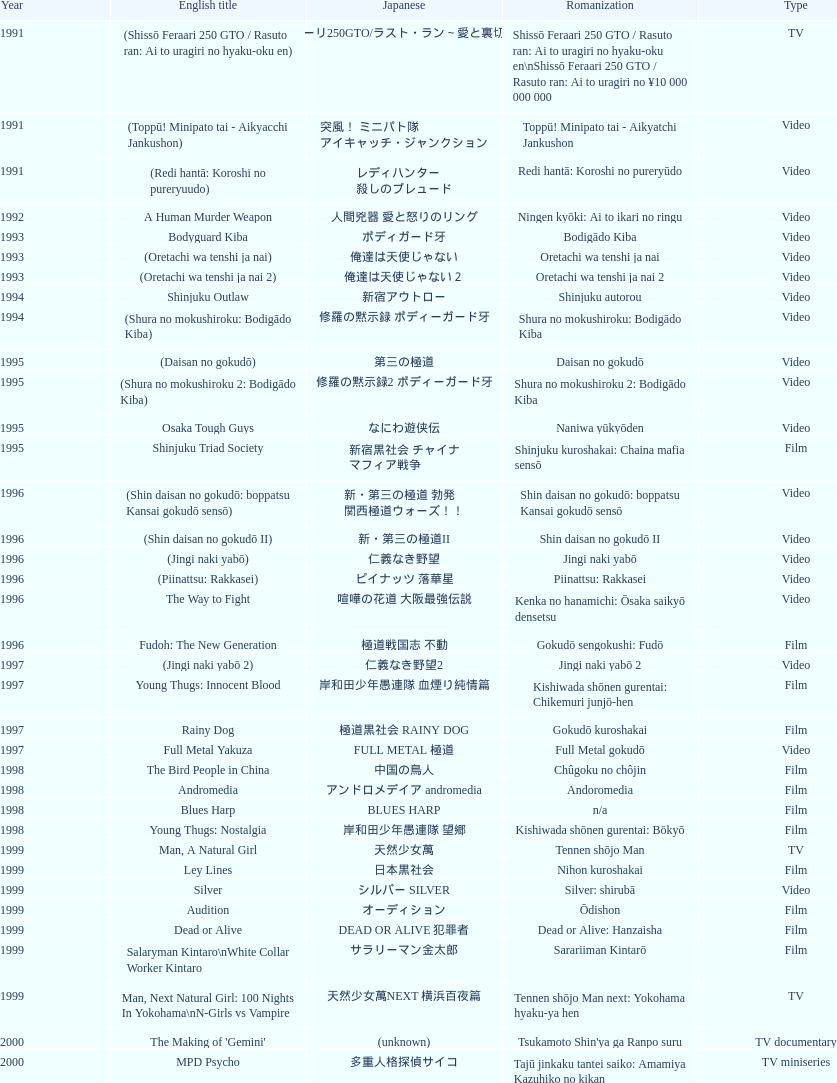Did shinjuku triad society come out as a film or a tv series? Film. 